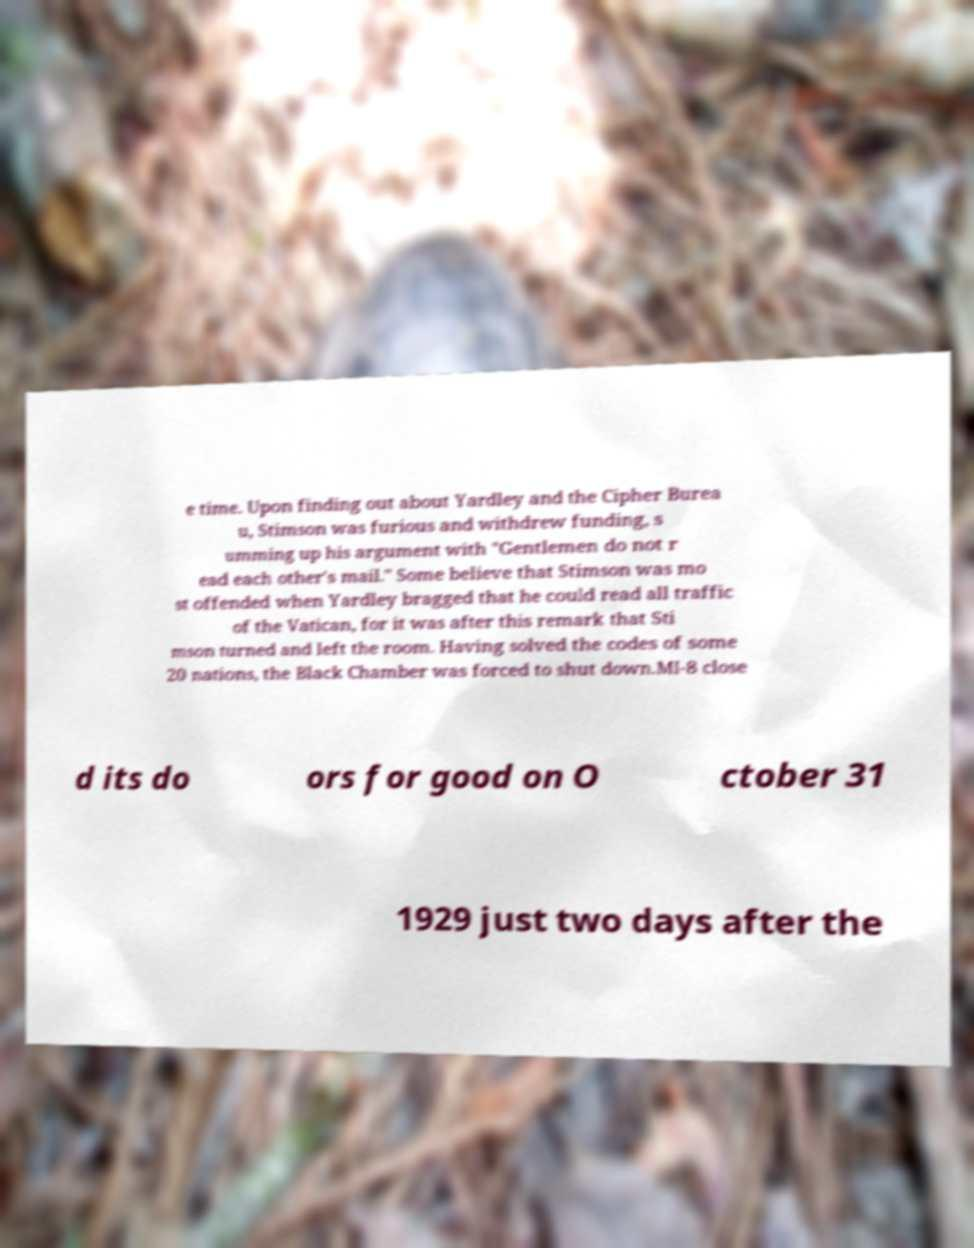Please read and relay the text visible in this image. What does it say? e time. Upon finding out about Yardley and the Cipher Burea u, Stimson was furious and withdrew funding, s umming up his argument with "Gentlemen do not r ead each other's mail." Some believe that Stimson was mo st offended when Yardley bragged that he could read all traffic of the Vatican, for it was after this remark that Sti mson turned and left the room. Having solved the codes of some 20 nations, the Black Chamber was forced to shut down.MI-8 close d its do ors for good on O ctober 31 1929 just two days after the 